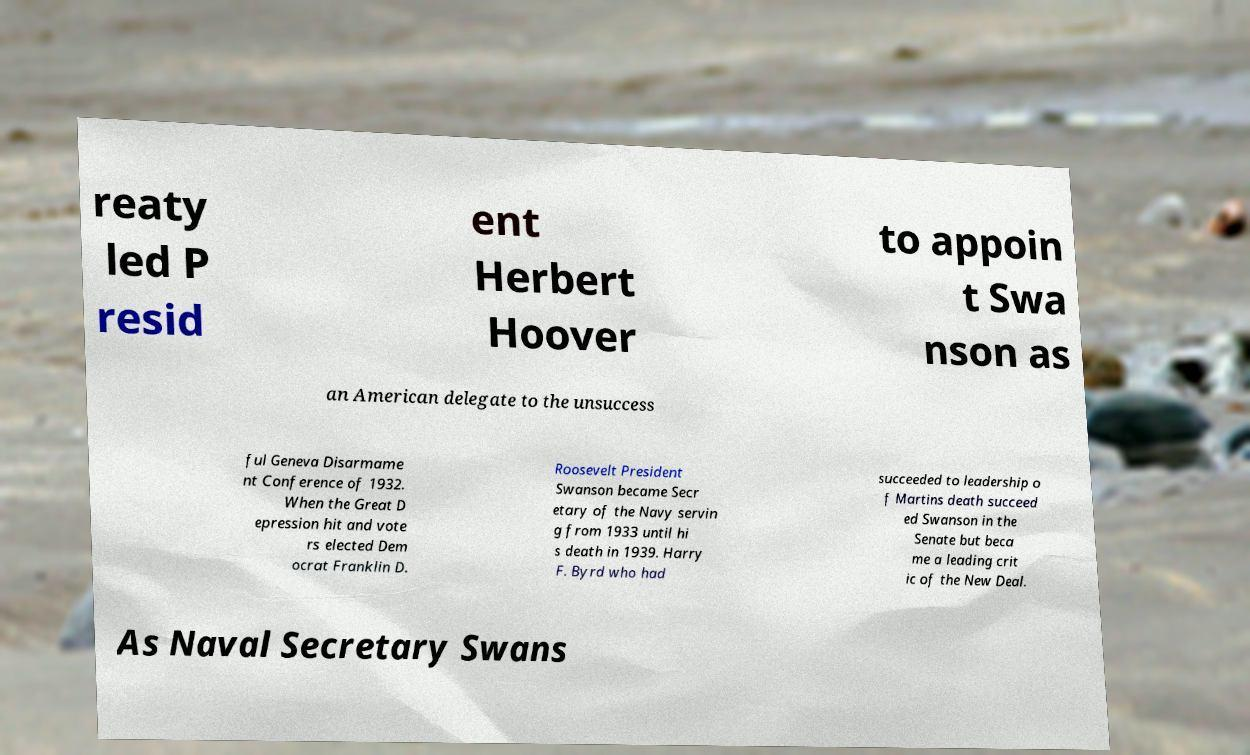For documentation purposes, I need the text within this image transcribed. Could you provide that? reaty led P resid ent Herbert Hoover to appoin t Swa nson as an American delegate to the unsuccess ful Geneva Disarmame nt Conference of 1932. When the Great D epression hit and vote rs elected Dem ocrat Franklin D. Roosevelt President Swanson became Secr etary of the Navy servin g from 1933 until hi s death in 1939. Harry F. Byrd who had succeeded to leadership o f Martins death succeed ed Swanson in the Senate but beca me a leading crit ic of the New Deal. As Naval Secretary Swans 